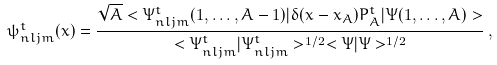Convert formula to latex. <formula><loc_0><loc_0><loc_500><loc_500>\psi _ { n l j m } ^ { t } ( x ) = \frac { \sqrt { A } < \Psi _ { n l j m } ^ { t } ( 1 , \dots , A - 1 ) | \delta ( x - x _ { A } ) P ^ { t } _ { A } | \Psi ( 1 , \dots , A ) > } { < \Psi _ { n l j m } ^ { t } | \Psi _ { n l j m } ^ { t } > ^ { 1 / 2 } < \Psi | \Psi > ^ { 1 / 2 } } \, ,</formula> 